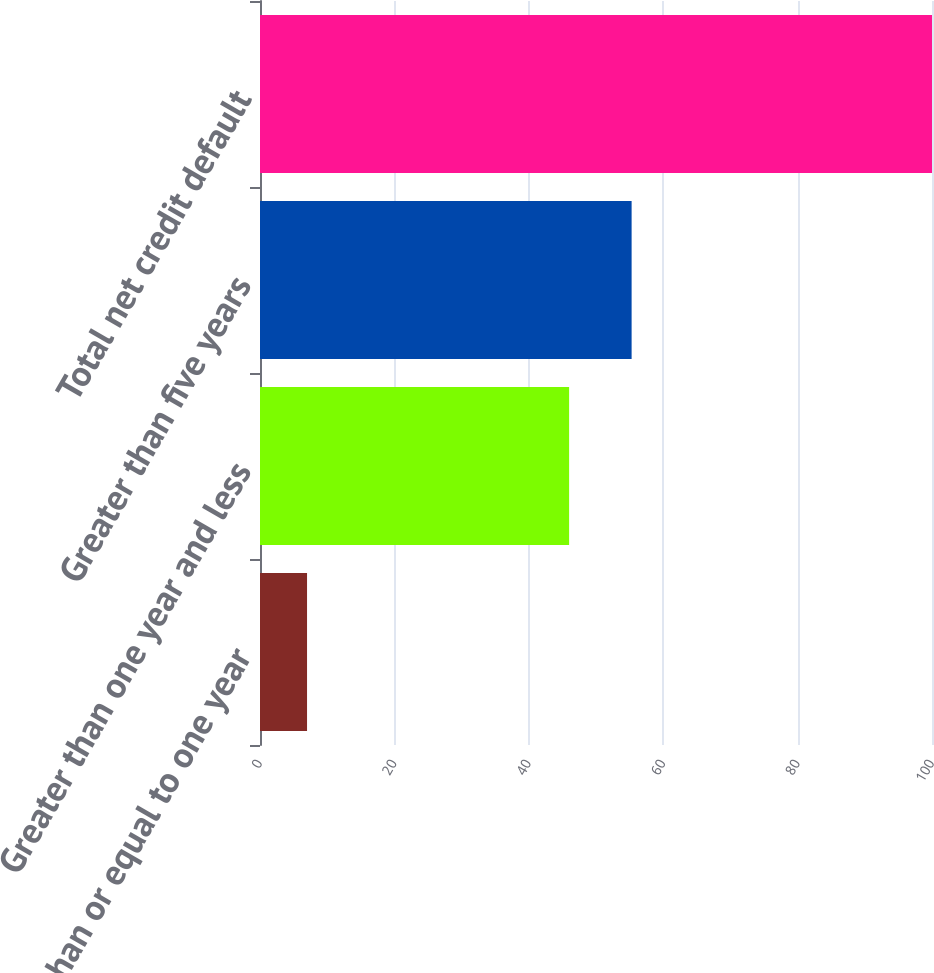Convert chart to OTSL. <chart><loc_0><loc_0><loc_500><loc_500><bar_chart><fcel>Less than or equal to one year<fcel>Greater than one year and less<fcel>Greater than five years<fcel>Total net credit default<nl><fcel>7<fcel>46<fcel>55.3<fcel>100<nl></chart> 